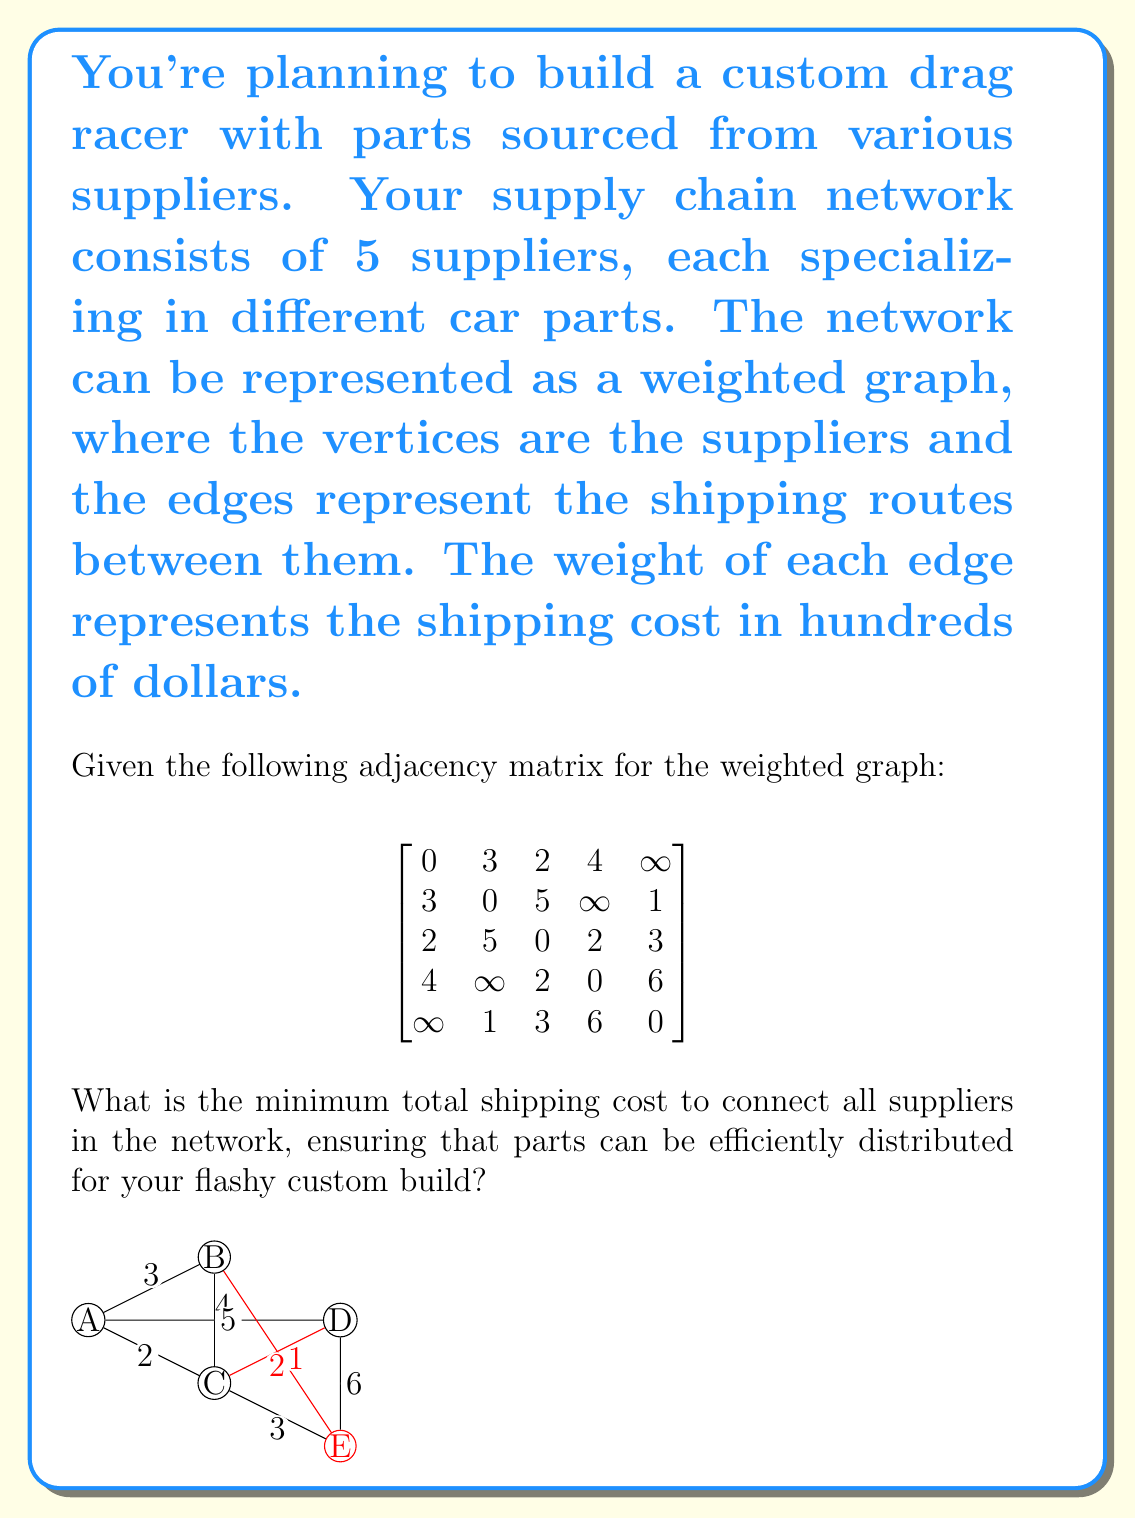Solve this math problem. To solve this problem, we need to find the minimum spanning tree (MST) of the given weighted graph. The MST will connect all suppliers with the minimum total shipping cost. We can use Kruskal's algorithm to find the MST:

1. Sort all edges by weight in ascending order:
   B-E (1), A-C (2), C-D (2), A-B (3), C-E (3), A-D (4), B-C (5), D-E (6)

2. Start with an empty set of edges and add edges in order, skipping those that would create a cycle:
   - Add B-E (1)
   - Add A-C (2)
   - Add C-D (2)
   - Add A-B (3)

3. We now have 4 edges connecting all 5 vertices, so we stop.

The minimum spanning tree consists of the edges:
B-E (1), A-C (2), C-D (2), A-B (3)

To calculate the total shipping cost:
$$ \text{Total cost} = 1 + 2 + 2 + 3 = 8 $$

Since the weights represent hundreds of dollars, the actual minimum total shipping cost is $800.

[asy]
unitsize(1cm);

pair A = (0,2);
pair B = (2,3);
pair C = (2,1);
pair D = (4,2);
pair E = (4,0);

draw(A--B, red+1);
draw(A--C, red+1);
draw(B--E, red+1);
draw(C--D, red+1);

dot("A", A, W);
dot("B", B, N);
dot("C", C, S);
dot("D", D, E);
dot("E", E, SE);

label("3", (A+B)/2, N);
label("2", (A+C)/2, W);
label("1", (B+E)/2, E);
label("2", (C+D)/2, S);
[/asy]
Answer: The minimum total shipping cost to connect all suppliers in the network is $800. 